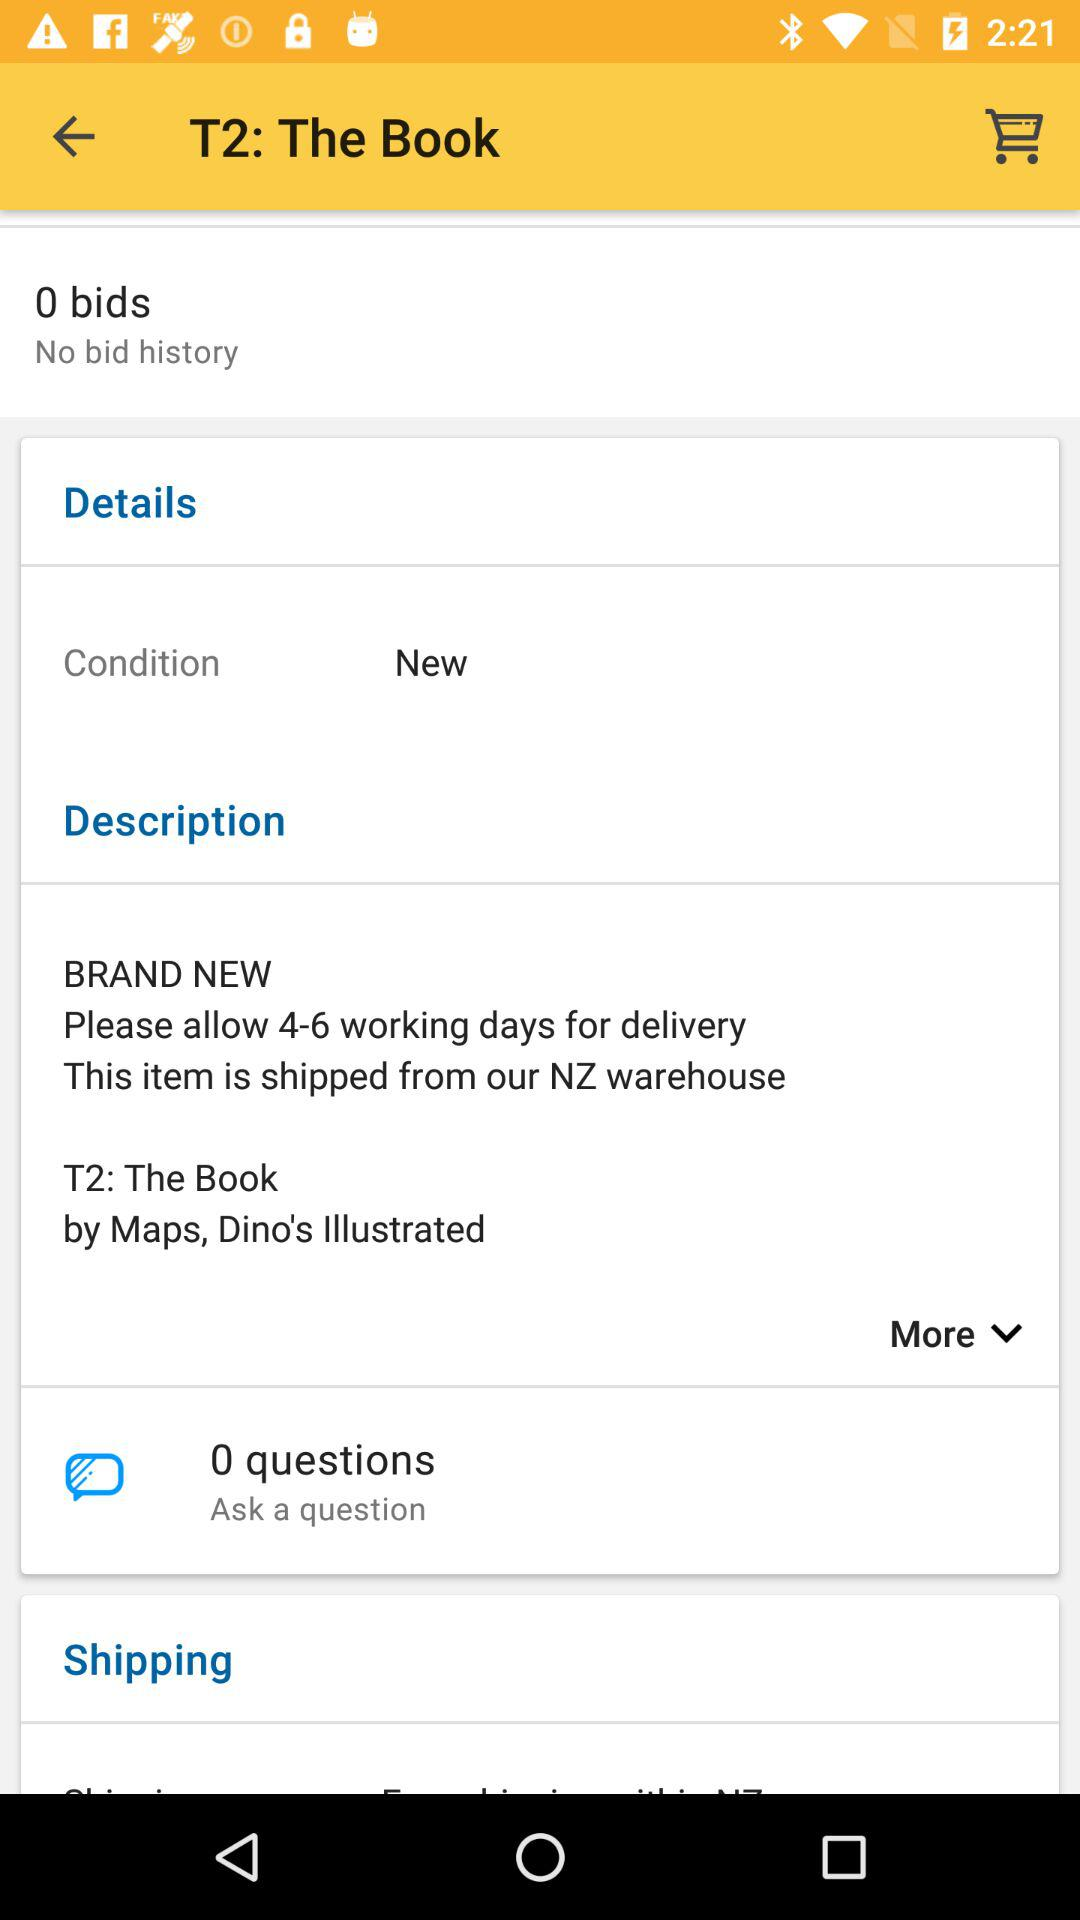Can you tell me more about the shipping information given for 'T2: The Book'? The shipping section specifies that the item will be dispatched from a warehouse in New Zealand and requests to allow 4-6 working days for delivery. 